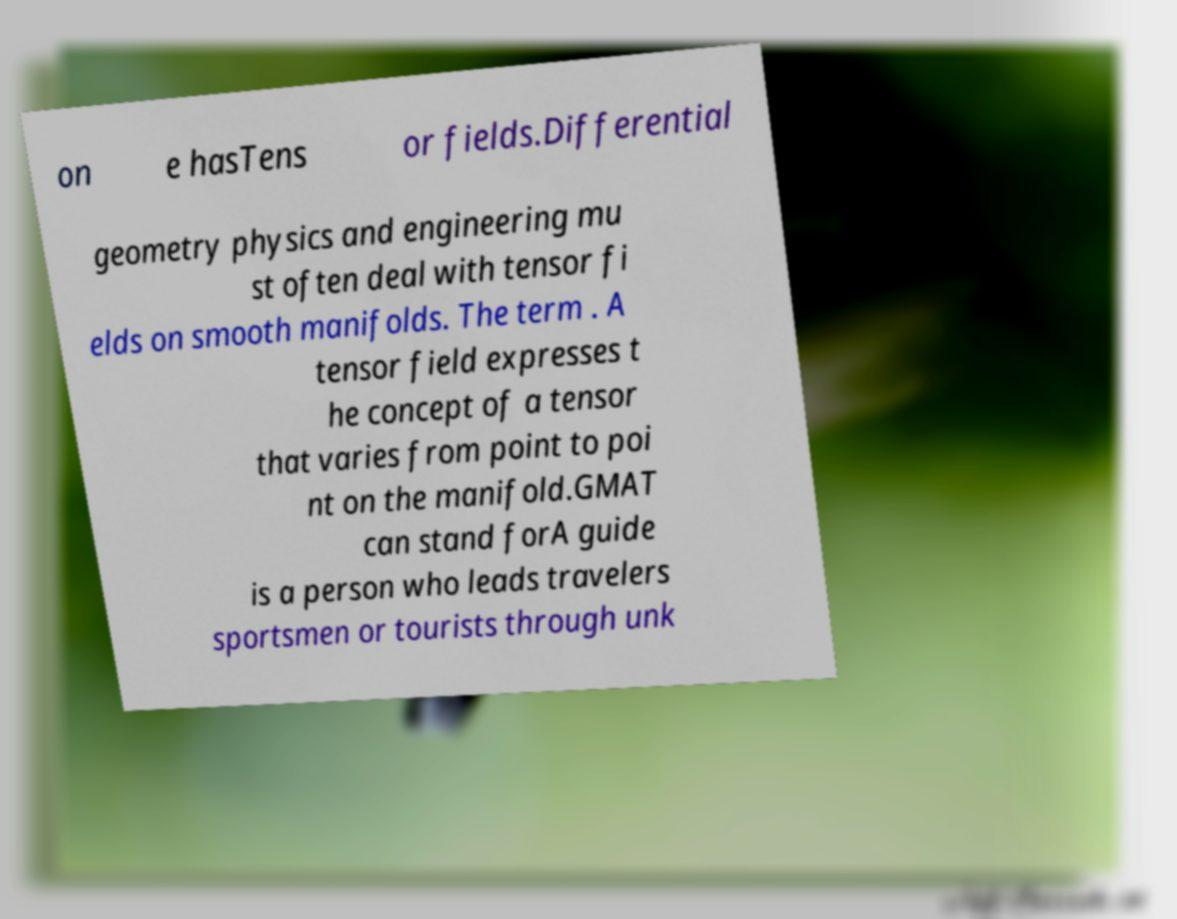Could you assist in decoding the text presented in this image and type it out clearly? on e hasTens or fields.Differential geometry physics and engineering mu st often deal with tensor fi elds on smooth manifolds. The term . A tensor field expresses t he concept of a tensor that varies from point to poi nt on the manifold.GMAT can stand forA guide is a person who leads travelers sportsmen or tourists through unk 